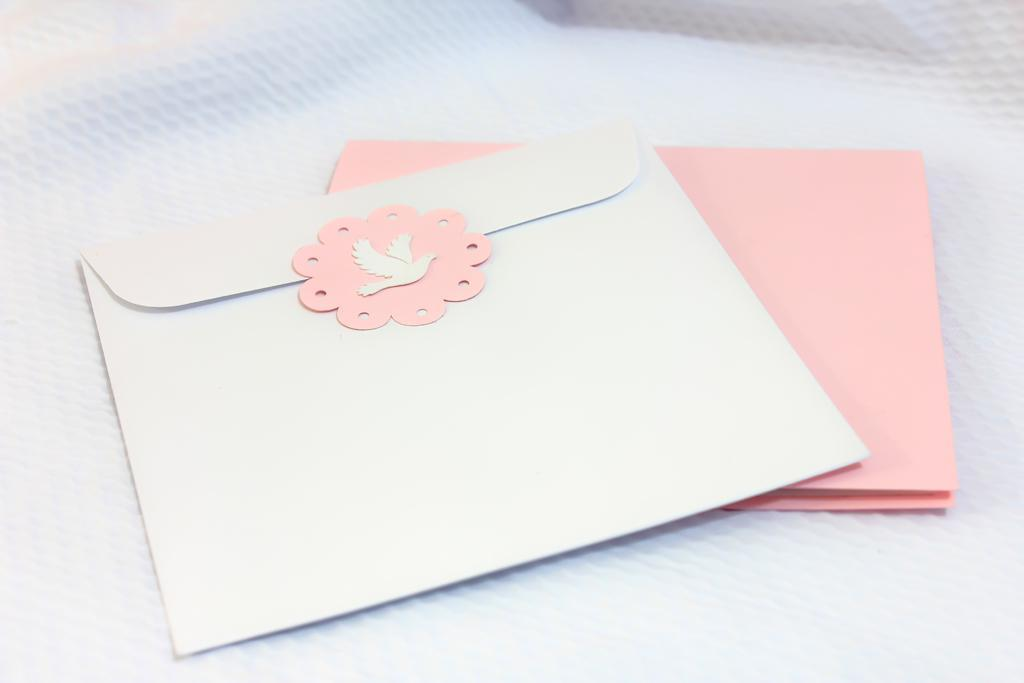What type of furniture is present in the image? There is a table in the image. What is covering the table? There is a white color cloth on the table. How many envelopes are on the table? There are two envelopes on the table. What are the colors of the envelopes? One envelope is white in color, and the other envelope is pink in color. What type of blade can be seen cutting through the white cloth on the table? There is no blade present in the image; the white cloth is simply covering the table. 